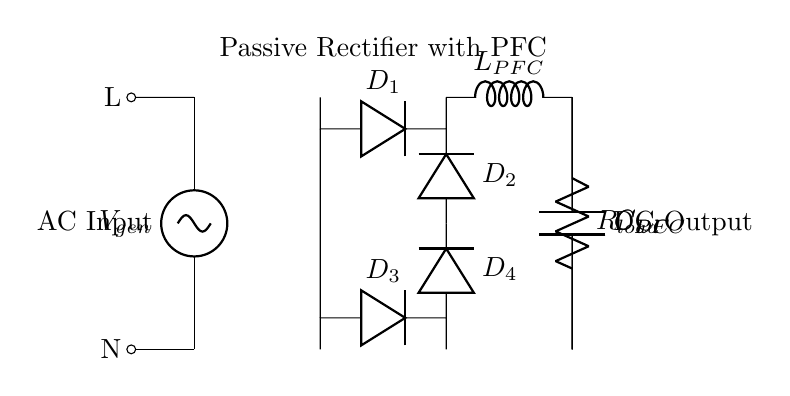What is the type of generator used in this circuit? The diagram indicates a hydroelectric generator, as labeled with "V_gen." This component converts mechanical energy into electrical energy using water flow.
Answer: hydroelectric How many diodes are in the bridge rectifier? The circuit shows four diodes labeled as D1, D2, D3, and D4, which are used to create the bridge rectifier for converting AC to DC.
Answer: four What is the function of the PFC inductor? The PFC inductor (labeled L_PFC) is used for power factor correction, which helps to improve the efficiency of the circuit. It stores energy and releases it in a controlled manner, minimizing the phase difference between voltage and current.
Answer: power factor correction What is the load resistance value in this circuit? The load resistor is labeled as R_load, which represents the resistance connected in the circuit to utilize the rectified voltage. The value is not specified, but it is indicated as a component in the circuit.
Answer: R_load Which component smooths the DC output voltage? The capacitor labeled C_DC is responsible for smoothing the output from the rectifier, reducing voltage ripple and providing steadier DC output to the load.
Answer: C_DC What is the AC input labeled as? The AC input is labeled as V_gen, which indicates the voltage generated by the hydroelectric generator prior to rectification.
Answer: V_gen Which two components are responsible for filtering in this circuit? The components C_PFC and C_DC function together; C_PFC works on the AC side, while C_DC filters the DC output, ensuring a stable voltage delivery to the load.
Answer: C_PFC and C_DC 